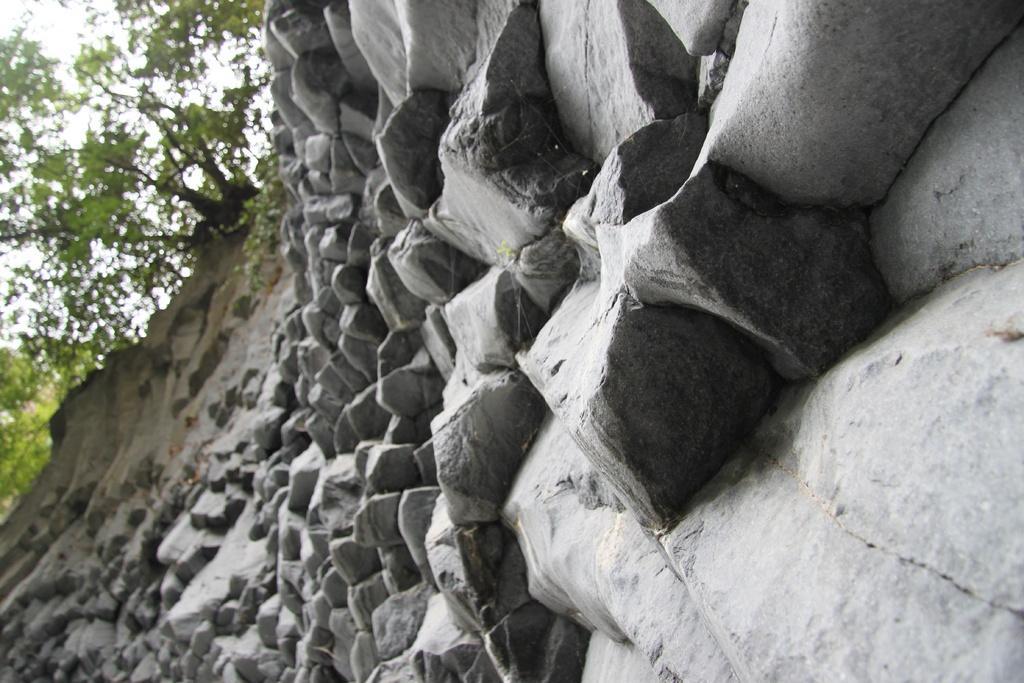Could you give a brief overview of what you see in this image? In this image we can see rocks, stones, trees and sky. 